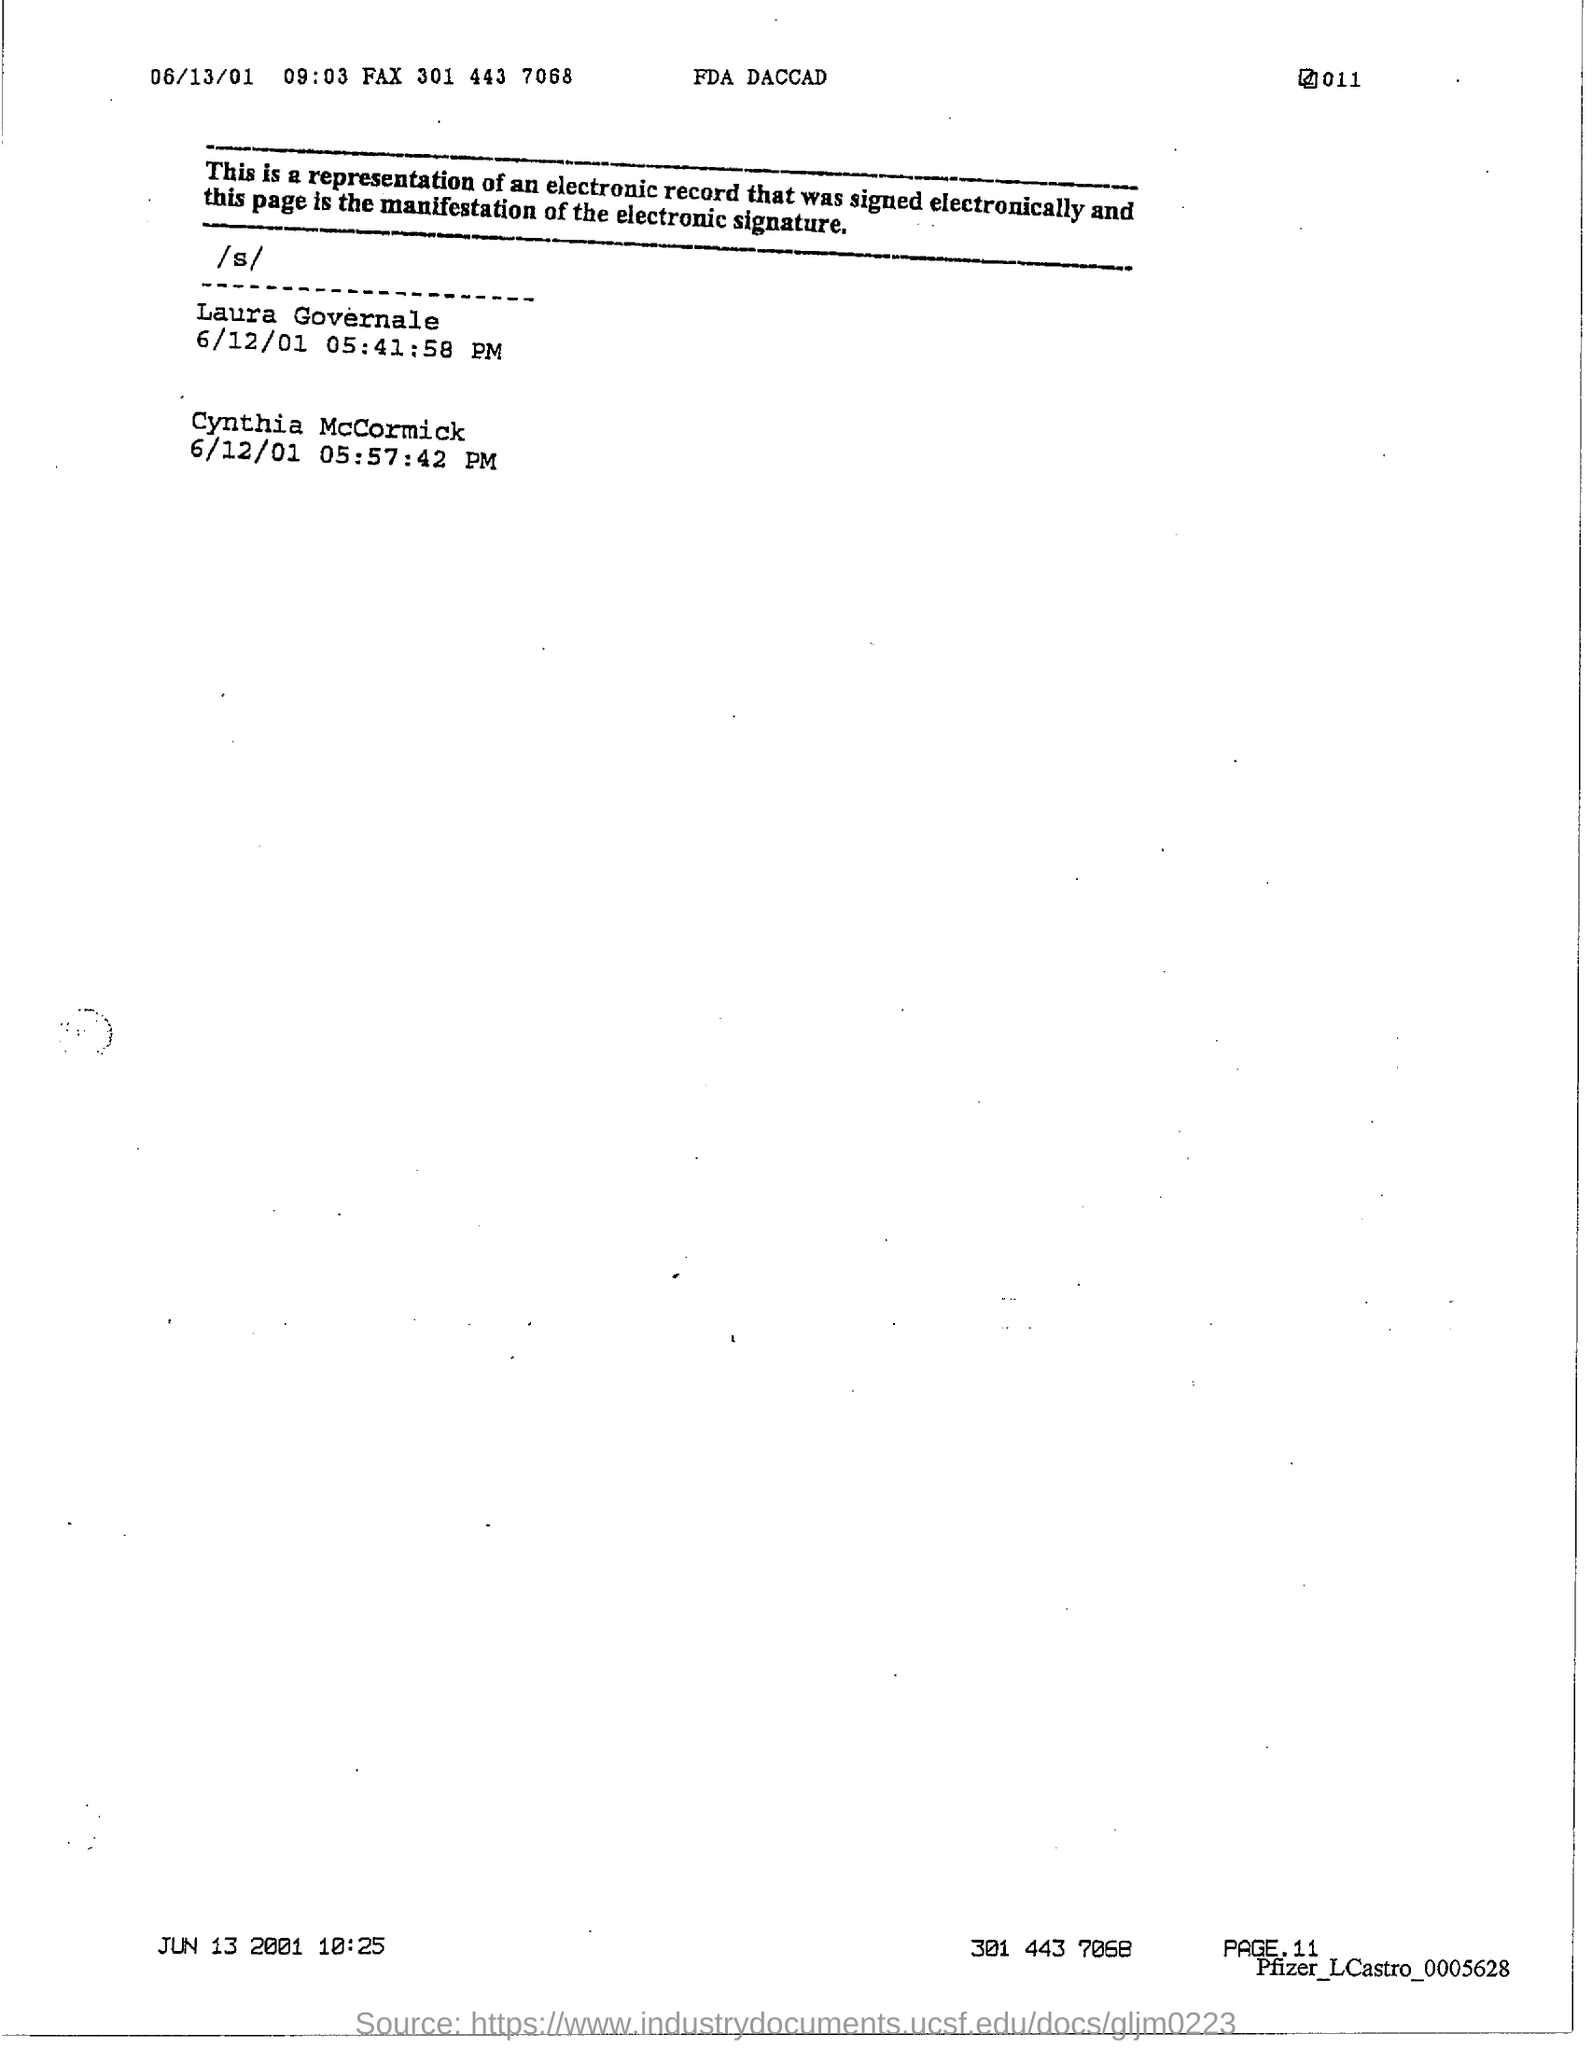Identify some key points in this picture. The page number at the bottom of the page is 11. 